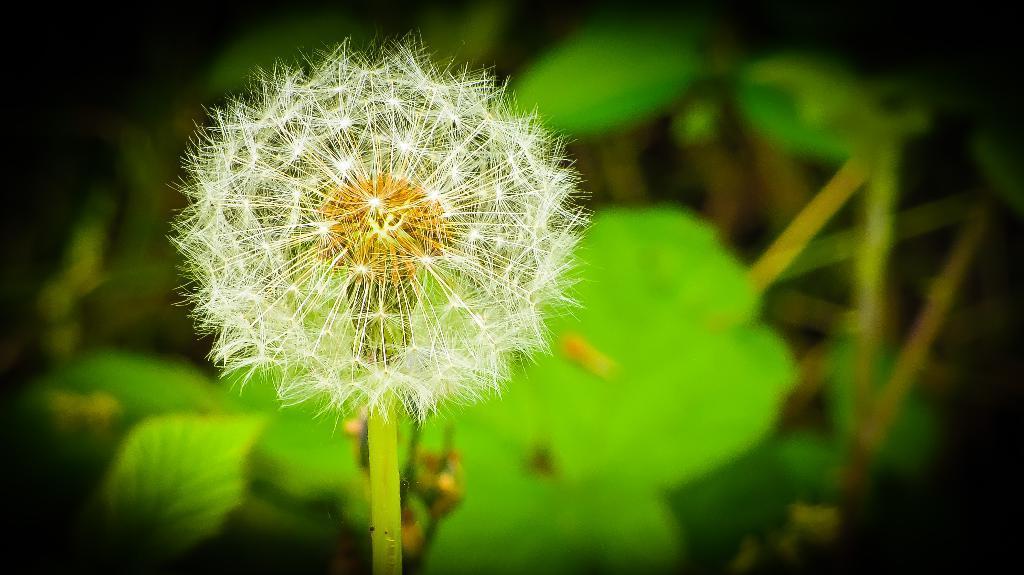In one or two sentences, can you explain what this image depicts? In this image in front there is a flower. In the background of the image there are leaves. 